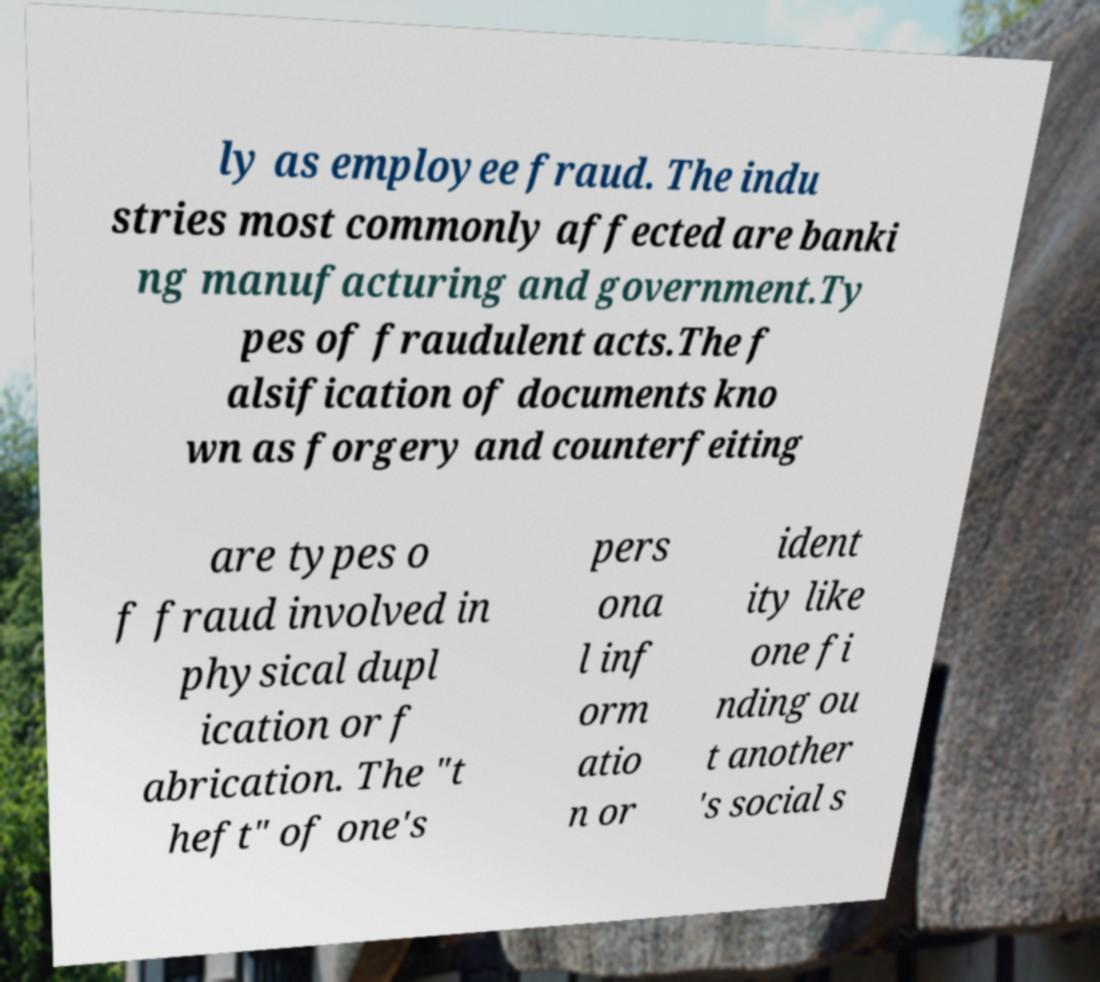Please identify and transcribe the text found in this image. ly as employee fraud. The indu stries most commonly affected are banki ng manufacturing and government.Ty pes of fraudulent acts.The f alsification of documents kno wn as forgery and counterfeiting are types o f fraud involved in physical dupl ication or f abrication. The "t heft" of one's pers ona l inf orm atio n or ident ity like one fi nding ou t another 's social s 